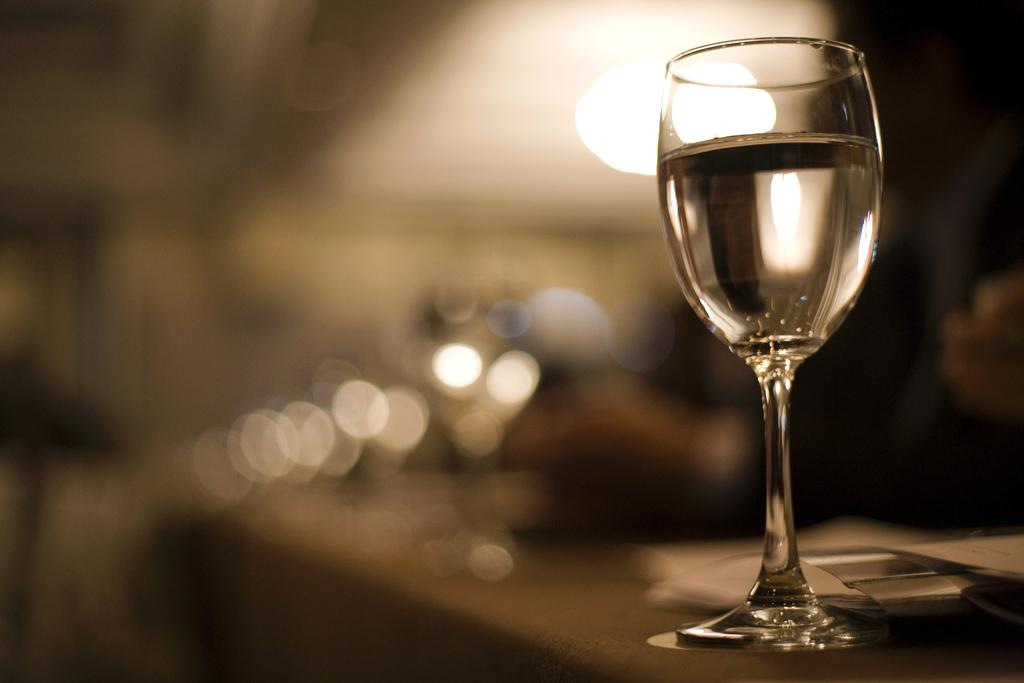What is on the table in the image? There is a glass of water on the table. What else can be seen on the table besides the glass of water? There are unspecified "things" on the table. Can you describe the background of the image? The background of the image is blurred. How does the grass feel in the image? There is no grass present in the image, so it is not possible to determine how it might feel. 